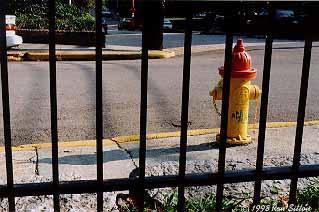How many horses are pulling the carriage?
Give a very brief answer. 0. 